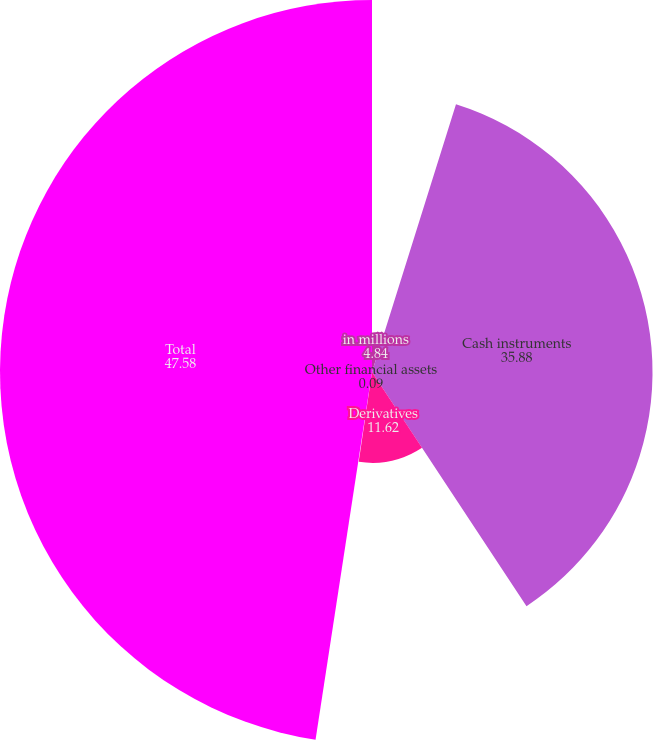Convert chart. <chart><loc_0><loc_0><loc_500><loc_500><pie_chart><fcel>in millions<fcel>Cash instruments<fcel>Derivatives<fcel>Other financial assets<fcel>Total<nl><fcel>4.84%<fcel>35.88%<fcel>11.62%<fcel>0.09%<fcel>47.58%<nl></chart> 